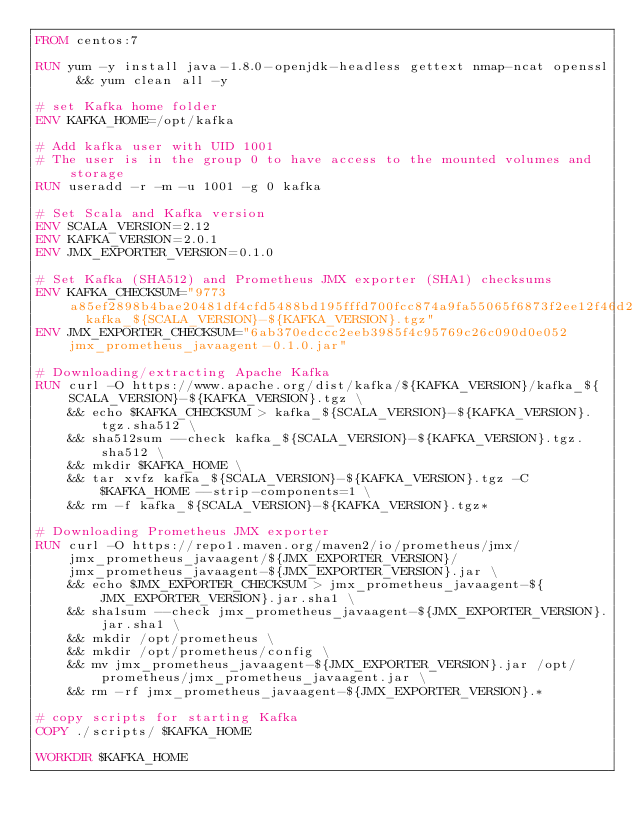<code> <loc_0><loc_0><loc_500><loc_500><_Dockerfile_>FROM centos:7

RUN yum -y install java-1.8.0-openjdk-headless gettext nmap-ncat openssl && yum clean all -y

# set Kafka home folder
ENV KAFKA_HOME=/opt/kafka

# Add kafka user with UID 1001
# The user is in the group 0 to have access to the mounted volumes and storage
RUN useradd -r -m -u 1001 -g 0 kafka

# Set Scala and Kafka version
ENV SCALA_VERSION=2.12
ENV KAFKA_VERSION=2.0.1
ENV JMX_EXPORTER_VERSION=0.1.0

# Set Kafka (SHA512) and Prometheus JMX exporter (SHA1) checksums
ENV KAFKA_CHECKSUM="9773a85ef2898b4bae20481df4cfd5488bd195fffd700fcc874a9fa55065f6873f2ee12f46d2f6a6ccb5d5a93ddb7dec19227aef5d39d4f72b545ec63b24bb2f  kafka_${SCALA_VERSION}-${KAFKA_VERSION}.tgz"
ENV JMX_EXPORTER_CHECKSUM="6ab370edccc2eeb3985f4c95769c26c090d0e052 jmx_prometheus_javaagent-0.1.0.jar"

# Downloading/extracting Apache Kafka
RUN curl -O https://www.apache.org/dist/kafka/${KAFKA_VERSION}/kafka_${SCALA_VERSION}-${KAFKA_VERSION}.tgz \
    && echo $KAFKA_CHECKSUM > kafka_${SCALA_VERSION}-${KAFKA_VERSION}.tgz.sha512 \
    && sha512sum --check kafka_${SCALA_VERSION}-${KAFKA_VERSION}.tgz.sha512 \
    && mkdir $KAFKA_HOME \
    && tar xvfz kafka_${SCALA_VERSION}-${KAFKA_VERSION}.tgz -C $KAFKA_HOME --strip-components=1 \
    && rm -f kafka_${SCALA_VERSION}-${KAFKA_VERSION}.tgz*

# Downloading Prometheus JMX exporter
RUN curl -O https://repo1.maven.org/maven2/io/prometheus/jmx/jmx_prometheus_javaagent/${JMX_EXPORTER_VERSION}/jmx_prometheus_javaagent-${JMX_EXPORTER_VERSION}.jar \
    && echo $JMX_EXPORTER_CHECKSUM > jmx_prometheus_javaagent-${JMX_EXPORTER_VERSION}.jar.sha1 \
    && sha1sum --check jmx_prometheus_javaagent-${JMX_EXPORTER_VERSION}.jar.sha1 \
    && mkdir /opt/prometheus \
    && mkdir /opt/prometheus/config \
    && mv jmx_prometheus_javaagent-${JMX_EXPORTER_VERSION}.jar /opt/prometheus/jmx_prometheus_javaagent.jar \
    && rm -rf jmx_prometheus_javaagent-${JMX_EXPORTER_VERSION}.*

# copy scripts for starting Kafka
COPY ./scripts/ $KAFKA_HOME

WORKDIR $KAFKA_HOME
</code> 